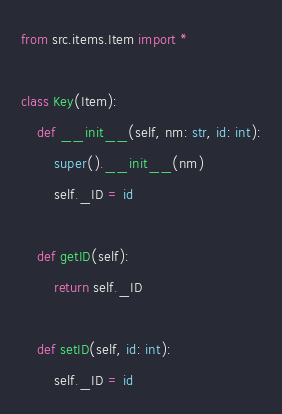Convert code to text. <code><loc_0><loc_0><loc_500><loc_500><_Python_>from src.items.Item import *

class Key(Item):
    def __init__(self, nm: str, id: int):
        super().__init__(nm)
        self._ID = id

    def getID(self):
        return self._ID

    def setID(self, id: int):
        self._ID = id</code> 